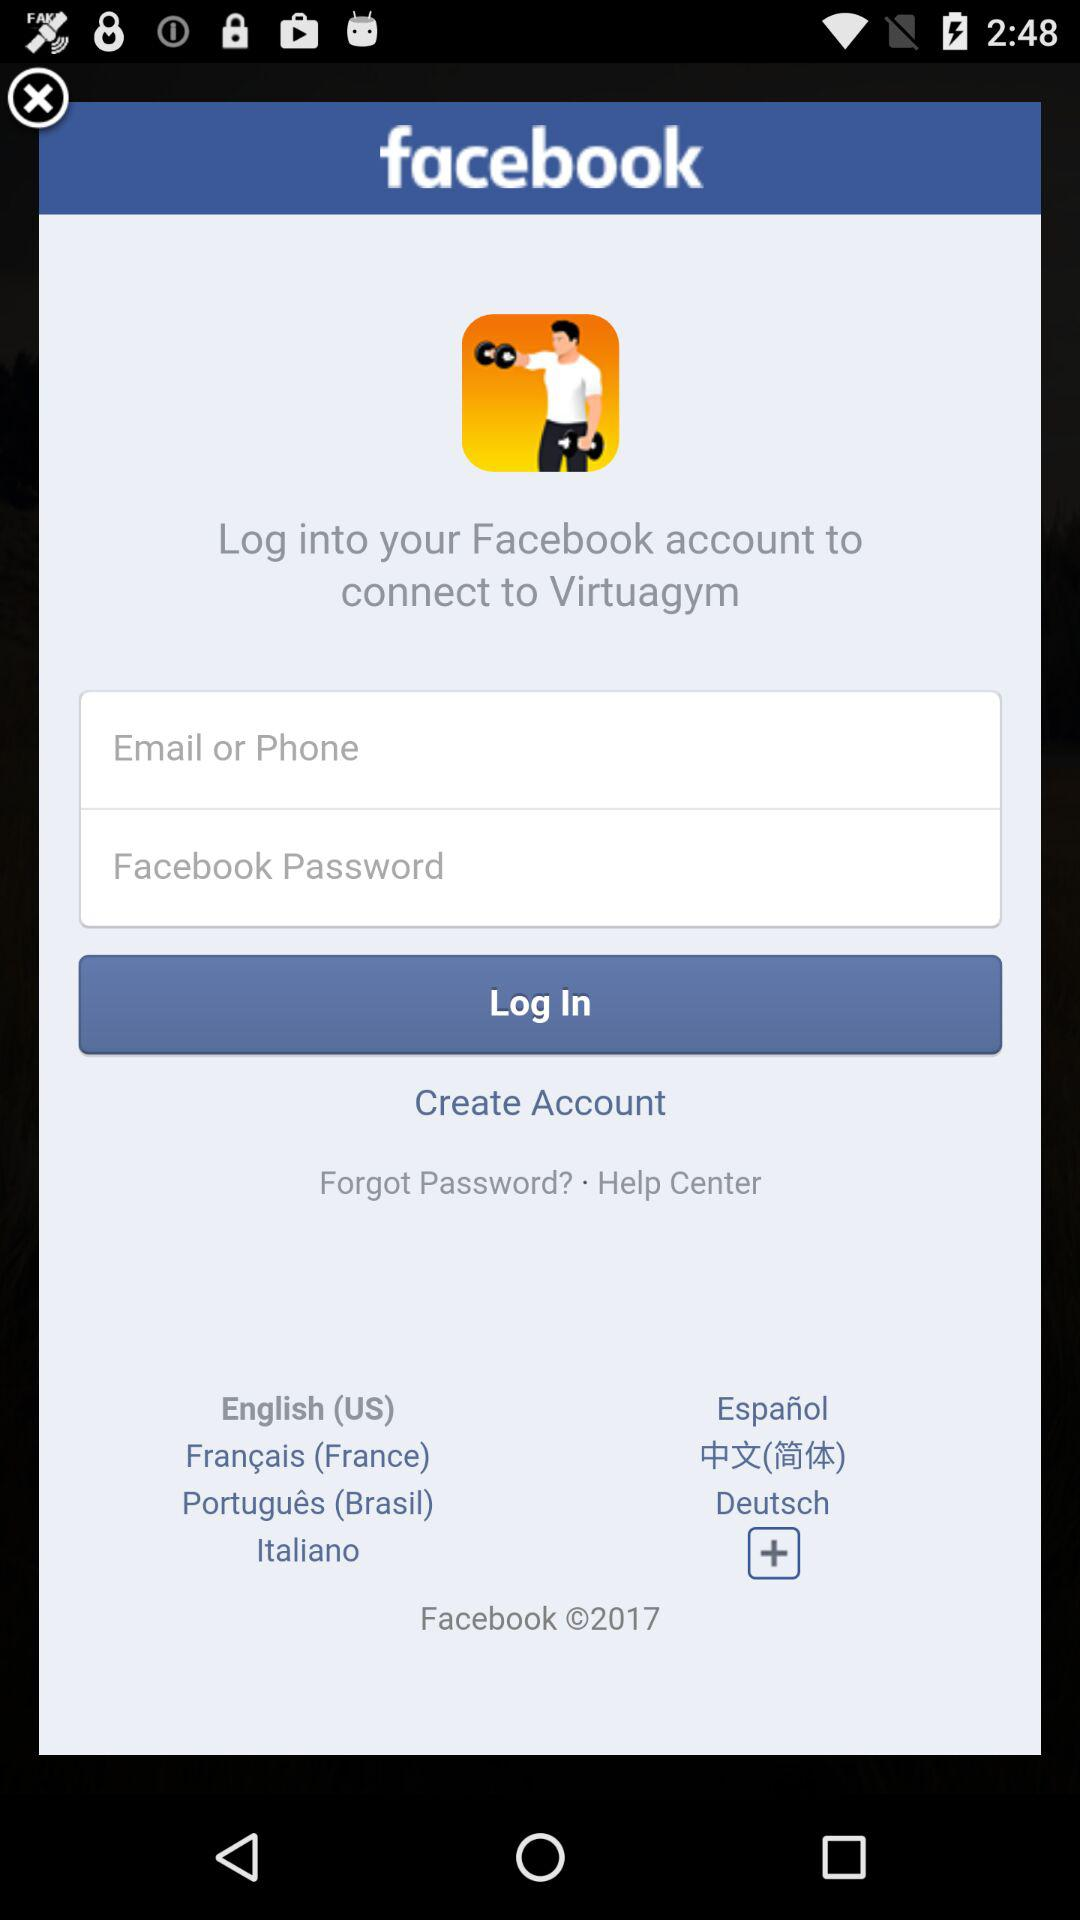What is the name of the application that connects via Facebook? The application is "Virtuagym". 